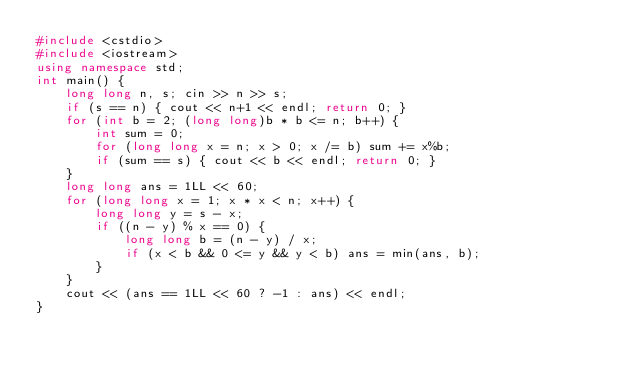Convert code to text. <code><loc_0><loc_0><loc_500><loc_500><_C++_>#include <cstdio>
#include <iostream>
using namespace std;
int main() {
    long long n, s; cin >> n >> s;
    if (s == n) { cout << n+1 << endl; return 0; }
    for (int b = 2; (long long)b * b <= n; b++) {
        int sum = 0;
        for (long long x = n; x > 0; x /= b) sum += x%b;
        if (sum == s) { cout << b << endl; return 0; }
    }
    long long ans = 1LL << 60;
    for (long long x = 1; x * x < n; x++) {
        long long y = s - x;
        if ((n - y) % x == 0) {
            long long b = (n - y) / x;
            if (x < b && 0 <= y && y < b) ans = min(ans, b);
        }
    }
    cout << (ans == 1LL << 60 ? -1 : ans) << endl;
}
</code> 